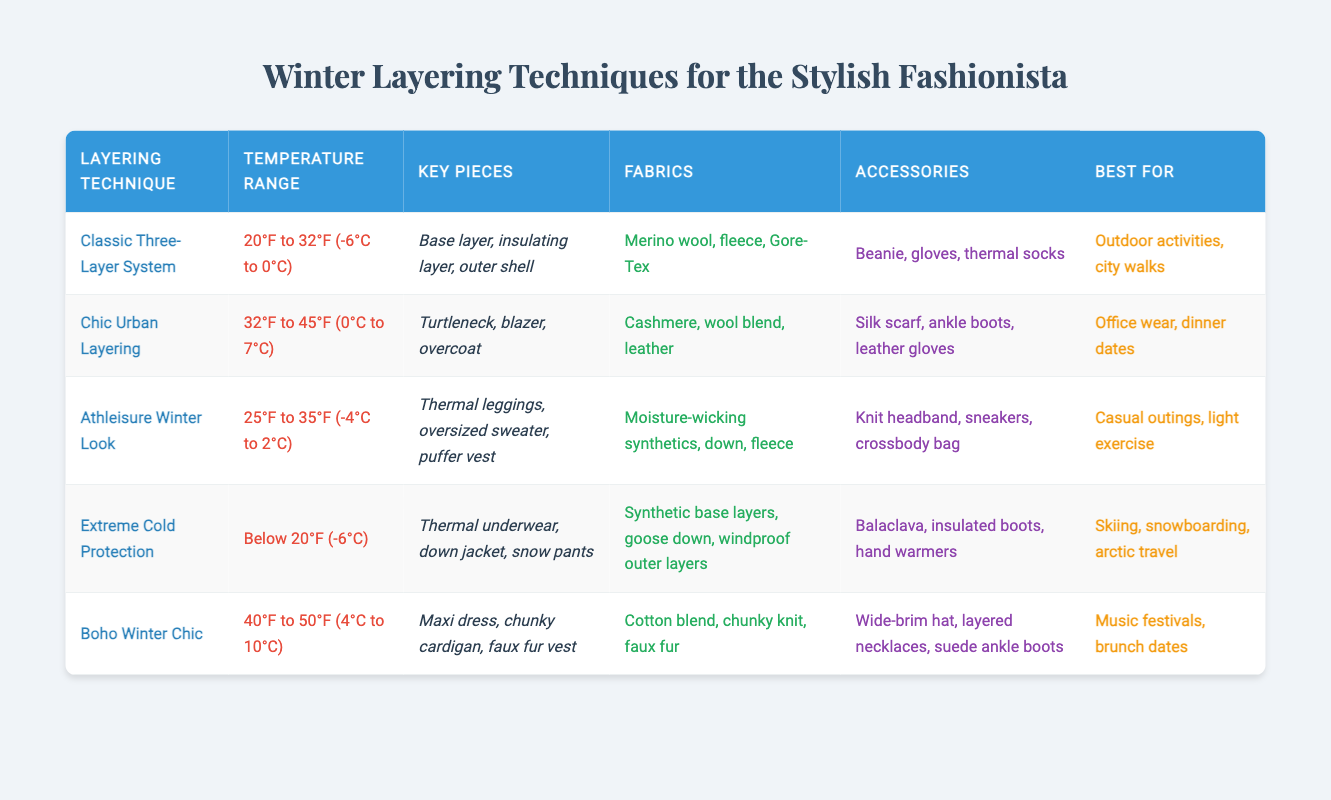What is the temperature range for the Classic Three-Layer System? The temperature range is displayed in the table under the "Temperature Range" column, specifically for the "Classic Three-Layer System," which states 20°F to 32°F (-6°C to 0°C).
Answer: 20°F to 32°F (-6°C to 0°C) Which layering technique is best for skiing? By reviewing the "Best for" column for each layering technique, it is clear that "Extreme Cold Protection" is the technique recommended for skiing, as it specifically mentions skiing, snowboarding, and arctic travel.
Answer: Extreme Cold Protection Are there any layering techniques that suggest using a beanie? Looking through the "Accessories" column, it is evident that the "Classic Three-Layer System" includes a beanie as one of its key accessories.
Answer: Yes What fabrics are recommended for the Chic Urban Layering technique? The table lists the recommended fabrics for "Chic Urban Layering" in the "Fabrics" column, which include cashmere, wool blend, and leather.
Answer: Cashmere, wool blend, leather Which layering technique is suitable for temperatures below 20°F? In the "Temperature Range" column, the only technique that specifies "Below 20°F (-6°C)" is "Extreme Cold Protection," making it the only option for that temperature level.
Answer: Extreme Cold Protection How many different layering techniques are suitable for temperatures above 40°F? The "Temperature Range" column indicates that "Boho Winter Chic" is the only technique that accommodates temperatures between 40°F to 50°F (4°C to 10°C), thus there is only one technique for this range.
Answer: 1 Is the Athleisure Winter Look appropriate for light exercise? The "Best for" column reveals that the "Athleisure Winter Look" is designated for casual outings and light exercise, confirming that it is indeed appropriate for that purpose.
Answer: Yes If I want to attend a brunch date, which layering technique should I choose? The table suggests that "Boho Winter Chic" is best for music festivals and brunch dates, which makes it the suitable choice for that event.
Answer: Boho Winter Chic 